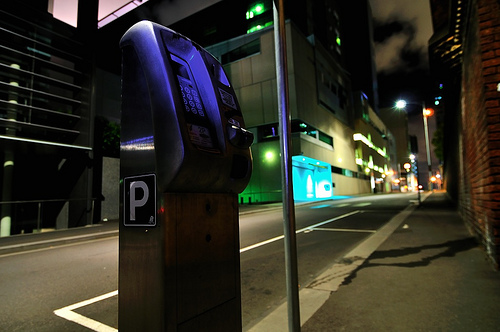Identify the text contained in this image. P 